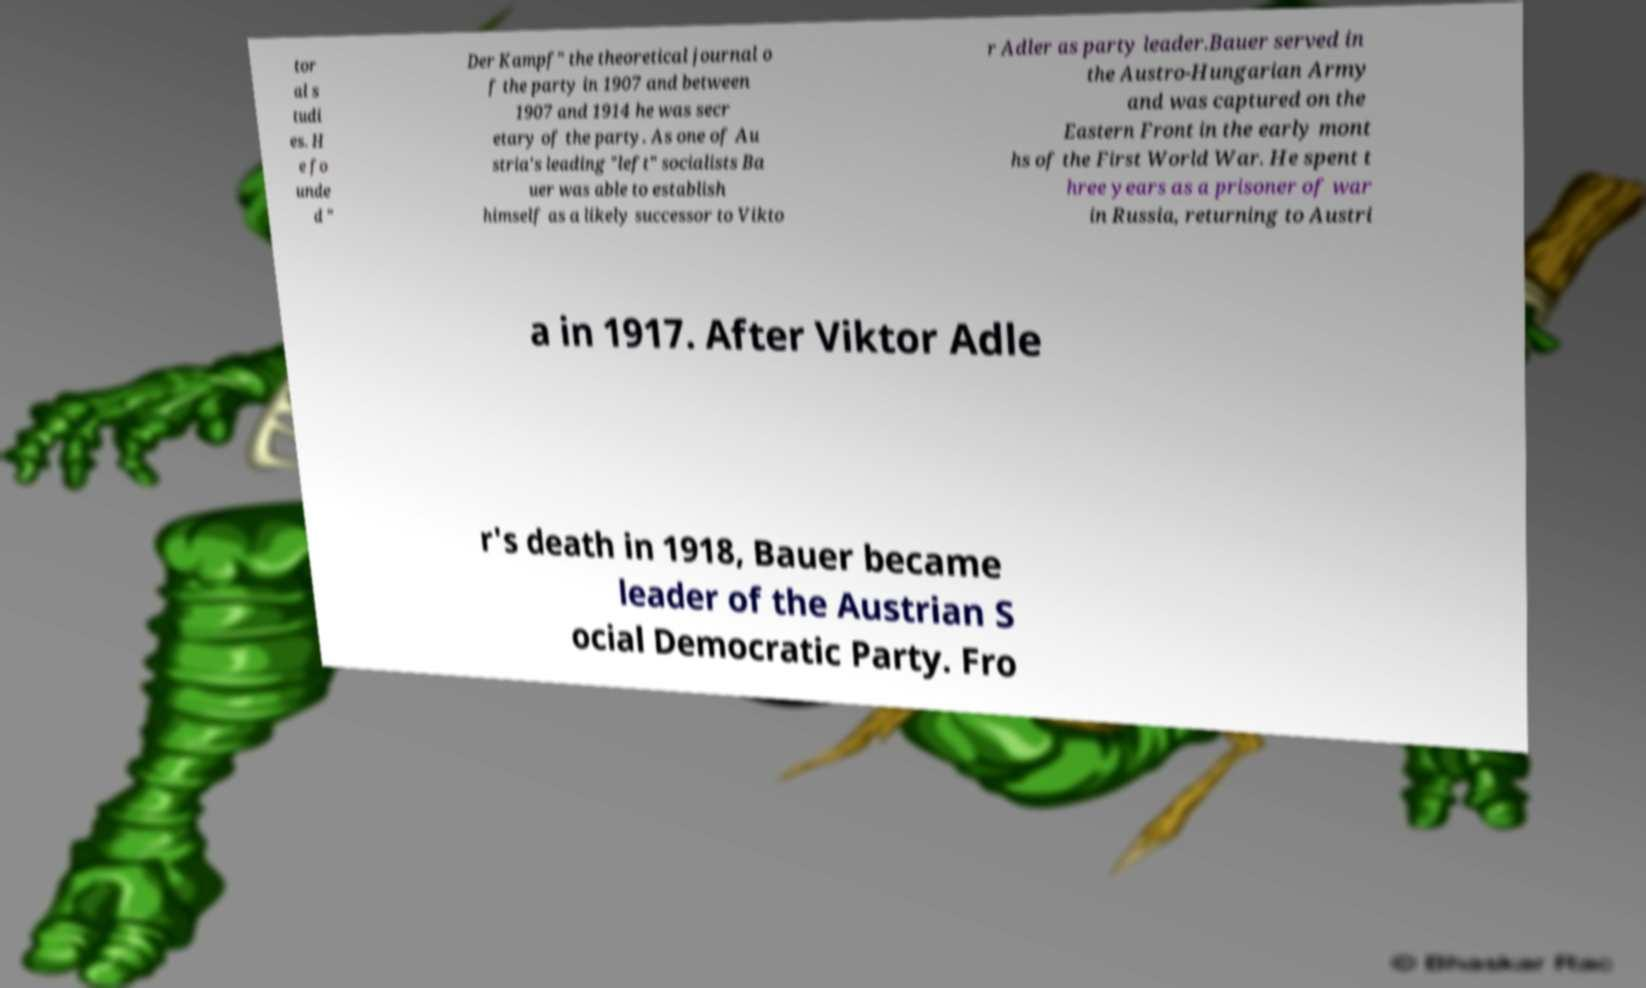Could you extract and type out the text from this image? tor al s tudi es. H e fo unde d " Der Kampf" the theoretical journal o f the party in 1907 and between 1907 and 1914 he was secr etary of the party. As one of Au stria's leading "left" socialists Ba uer was able to establish himself as a likely successor to Vikto r Adler as party leader.Bauer served in the Austro-Hungarian Army and was captured on the Eastern Front in the early mont hs of the First World War. He spent t hree years as a prisoner of war in Russia, returning to Austri a in 1917. After Viktor Adle r's death in 1918, Bauer became leader of the Austrian S ocial Democratic Party. Fro 